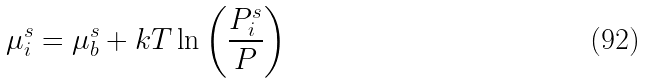Convert formula to latex. <formula><loc_0><loc_0><loc_500><loc_500>\mu _ { i } ^ { s } = \mu _ { b } ^ { s } + k T \ln \left ( \frac { P _ { i } ^ { s } } { P } \right )</formula> 